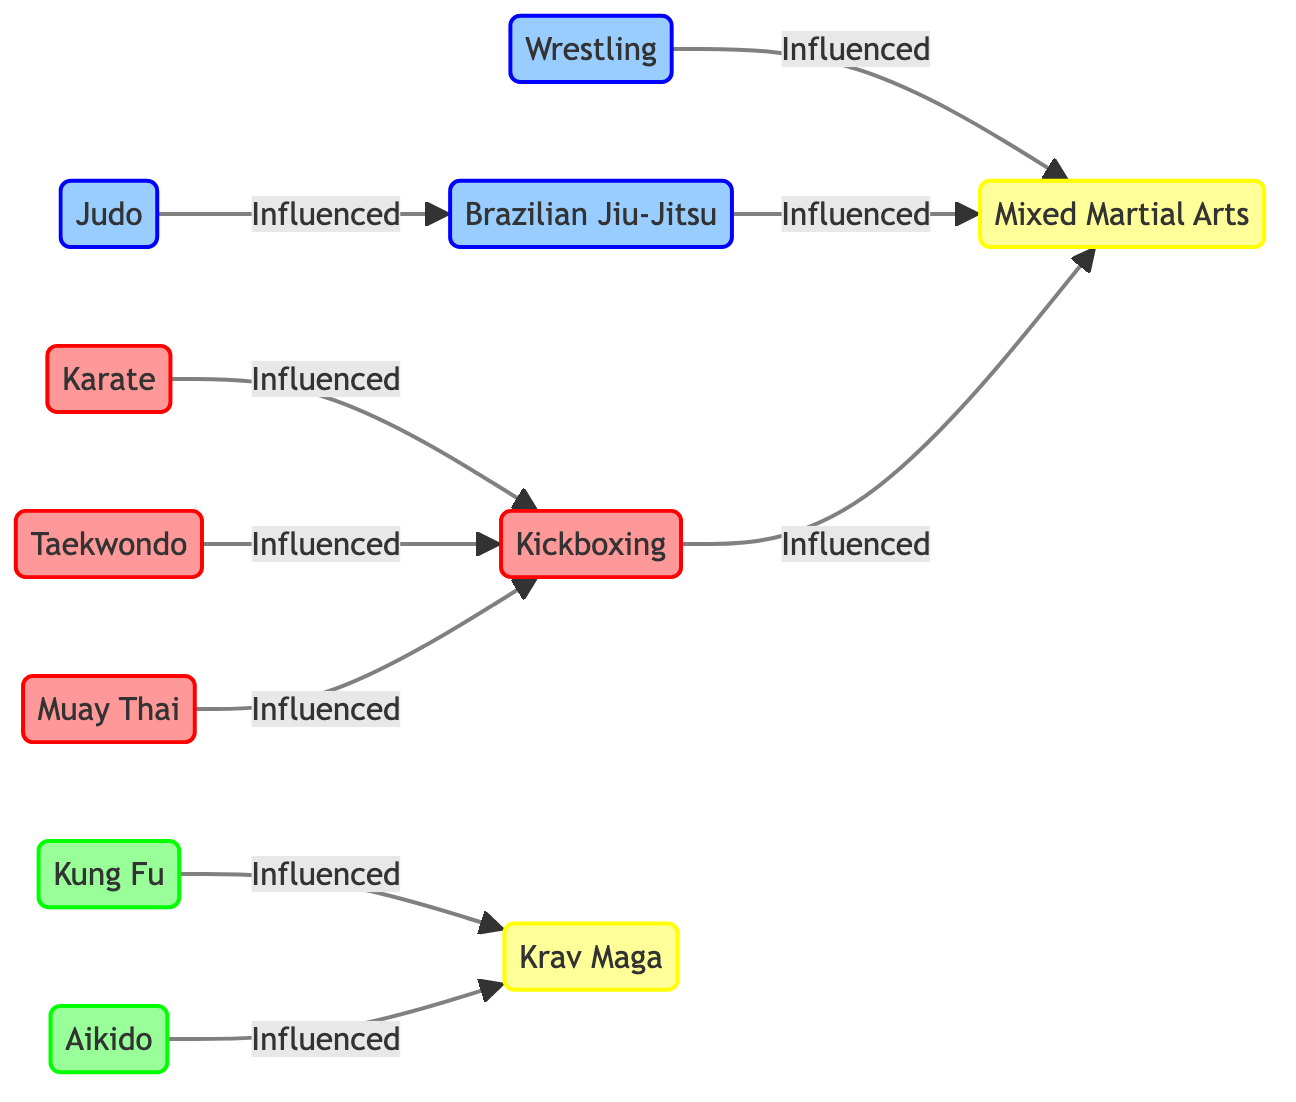What is the total number of nodes in the diagram? The nodes listed in the diagram are Karate, Taekwondo, Muay Thai, Kickboxing, Judo, Brazilian Jiu-Jitsu, Wrestling, Kung Fu, Aikido, Krav Maga, and Mixed Martial Arts. Counting these nodes, there are a total of 11 distinct types of martial arts styles represented.
Answer: 11 Which style is influenced by both Judo and Wrestling? From the diagram, Brazilian Jiu-Jitsu is connected with an "Influenced" relationship to Judo and also connected to Wrestling. This indicates that both styles have influenced Brazilian Jiu-Jitsu.
Answer: Brazilian Jiu-Jitsu How many styles are classified under the Striking group? By examining the nodes, Karate, Taekwondo, Muay Thai, and Kickboxing are classified as Striking styles. Counting these entries, there are 4 styles in this category.
Answer: 4 Which style influences Mixed Martial Arts primarily? Looking at the relationships in the diagram, Kickboxing, Brazilian Jiu-Jitsu, and Wrestling all have direct lines indicating they influence Mixed Martial Arts. Analyzing this, we conclude that all three styles primarily influence Mixed Martial Arts.
Answer: Kickboxing, Brazilian Jiu-Jitsu, Wrestling Which two Traditional styles influence Krav Maga? The edges show that both Kung Fu and Aikido have an "Influenced" relationship directed toward Krav Maga, indicating they each act as influences on Krav Maga.
Answer: Kung Fu, Aikido 